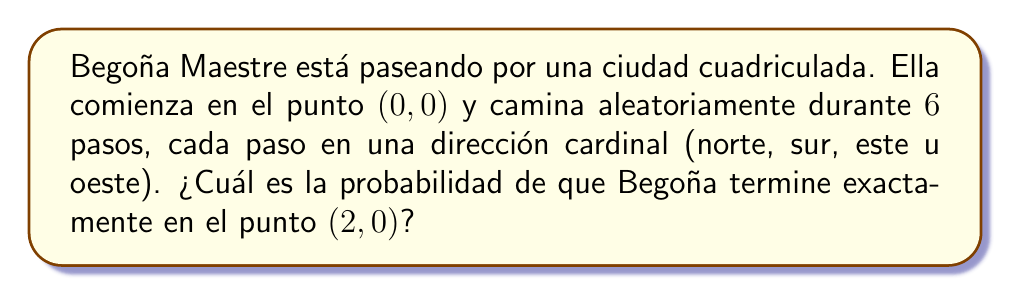Could you help me with this problem? Para resolver este problema, seguiremos estos pasos:

1) Primero, notemos que para llegar al punto (2,0), Begoña necesita moverse 2 pasos más hacia el este que hacia el oeste, y el mismo número de pasos hacia el norte que hacia el sur.

2) El número total de pasos es 6, y necesitamos 2 pasos netos hacia el este. Esto significa que necesitamos 4 pasos en el eje x (2 hacia el este y 2 hacia el oeste) y 2 pasos en el eje y (1 hacia el norte y 1 hacia el sur, en cualquier orden).

3) El número de formas de elegir 4 pasos de 6 para el movimiento en el eje x es:

   $$\binom{6}{4} = \frac{6!}{4!(6-4)!} = \frac{6!}{4!2!} = 15$$

4) De estos 4 pasos en el eje x, necesitamos exactamente 2 hacia el este. Esto se puede calcular como:

   $$\binom{4}{2} = \frac{4!}{2!2!} = 6$$

5) Los 2 pasos restantes en el eje y pueden ser en cualquier orden (norte-sur o sur-norte), lo que da 2 posibilidades.

6) Por lo tanto, el número total de caminos favorables es:

   $$6 \times 2 = 12$$

7) El número total de posibles caminos de 6 pasos es $4^6 = 4096$, ya que en cada paso hay 4 opciones.

8) La probabilidad es entonces:

   $$P(\text{llegar a (2,0)}) = \frac{12}{4096} = \frac{3}{1024} \approx 0.00293$$
Answer: $\frac{3}{1024}$ 